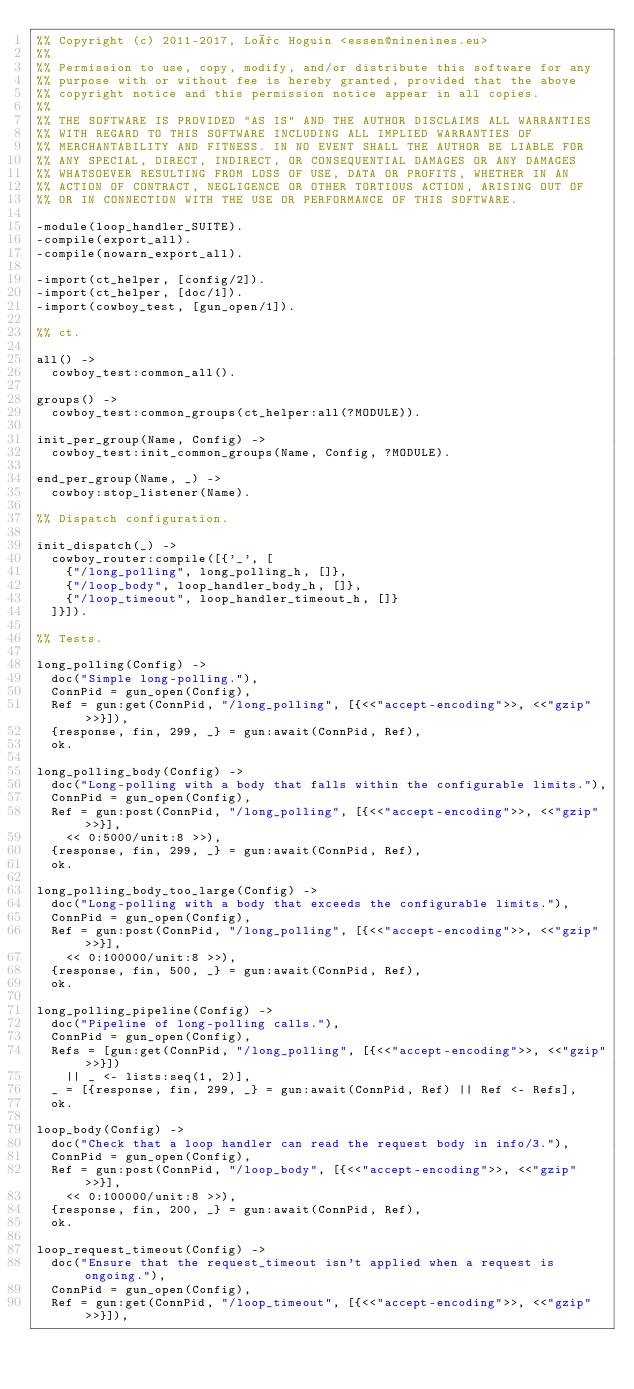<code> <loc_0><loc_0><loc_500><loc_500><_Erlang_>%% Copyright (c) 2011-2017, Loïc Hoguin <essen@ninenines.eu>
%%
%% Permission to use, copy, modify, and/or distribute this software for any
%% purpose with or without fee is hereby granted, provided that the above
%% copyright notice and this permission notice appear in all copies.
%%
%% THE SOFTWARE IS PROVIDED "AS IS" AND THE AUTHOR DISCLAIMS ALL WARRANTIES
%% WITH REGARD TO THIS SOFTWARE INCLUDING ALL IMPLIED WARRANTIES OF
%% MERCHANTABILITY AND FITNESS. IN NO EVENT SHALL THE AUTHOR BE LIABLE FOR
%% ANY SPECIAL, DIRECT, INDIRECT, OR CONSEQUENTIAL DAMAGES OR ANY DAMAGES
%% WHATSOEVER RESULTING FROM LOSS OF USE, DATA OR PROFITS, WHETHER IN AN
%% ACTION OF CONTRACT, NEGLIGENCE OR OTHER TORTIOUS ACTION, ARISING OUT OF
%% OR IN CONNECTION WITH THE USE OR PERFORMANCE OF THIS SOFTWARE.

-module(loop_handler_SUITE).
-compile(export_all).
-compile(nowarn_export_all).

-import(ct_helper, [config/2]).
-import(ct_helper, [doc/1]).
-import(cowboy_test, [gun_open/1]).

%% ct.

all() ->
	cowboy_test:common_all().

groups() ->
	cowboy_test:common_groups(ct_helper:all(?MODULE)).

init_per_group(Name, Config) ->
	cowboy_test:init_common_groups(Name, Config, ?MODULE).

end_per_group(Name, _) ->
	cowboy:stop_listener(Name).

%% Dispatch configuration.

init_dispatch(_) ->
	cowboy_router:compile([{'_', [
		{"/long_polling", long_polling_h, []},
		{"/loop_body", loop_handler_body_h, []},
		{"/loop_timeout", loop_handler_timeout_h, []}
	]}]).

%% Tests.

long_polling(Config) ->
	doc("Simple long-polling."),
	ConnPid = gun_open(Config),
	Ref = gun:get(ConnPid, "/long_polling", [{<<"accept-encoding">>, <<"gzip">>}]),
	{response, fin, 299, _} = gun:await(ConnPid, Ref),
	ok.

long_polling_body(Config) ->
	doc("Long-polling with a body that falls within the configurable limits."),
	ConnPid = gun_open(Config),
	Ref = gun:post(ConnPid, "/long_polling", [{<<"accept-encoding">>, <<"gzip">>}],
		<< 0:5000/unit:8 >>),
	{response, fin, 299, _} = gun:await(ConnPid, Ref),
	ok.

long_polling_body_too_large(Config) ->
	doc("Long-polling with a body that exceeds the configurable limits."),
	ConnPid = gun_open(Config),
	Ref = gun:post(ConnPid, "/long_polling", [{<<"accept-encoding">>, <<"gzip">>}],
		<< 0:100000/unit:8 >>),
	{response, fin, 500, _} = gun:await(ConnPid, Ref),
	ok.

long_polling_pipeline(Config) ->
	doc("Pipeline of long-polling calls."),
	ConnPid = gun_open(Config),
	Refs = [gun:get(ConnPid, "/long_polling", [{<<"accept-encoding">>, <<"gzip">>}])
		|| _ <- lists:seq(1, 2)],
	_ = [{response, fin, 299, _} = gun:await(ConnPid, Ref) || Ref <- Refs],
	ok.

loop_body(Config) ->
	doc("Check that a loop handler can read the request body in info/3."),
	ConnPid = gun_open(Config),
	Ref = gun:post(ConnPid, "/loop_body", [{<<"accept-encoding">>, <<"gzip">>}],
		<< 0:100000/unit:8 >>),
	{response, fin, 200, _} = gun:await(ConnPid, Ref),
	ok.

loop_request_timeout(Config) ->
	doc("Ensure that the request_timeout isn't applied when a request is ongoing."),
	ConnPid = gun_open(Config),
	Ref = gun:get(ConnPid, "/loop_timeout", [{<<"accept-encoding">>, <<"gzip">>}]),</code> 